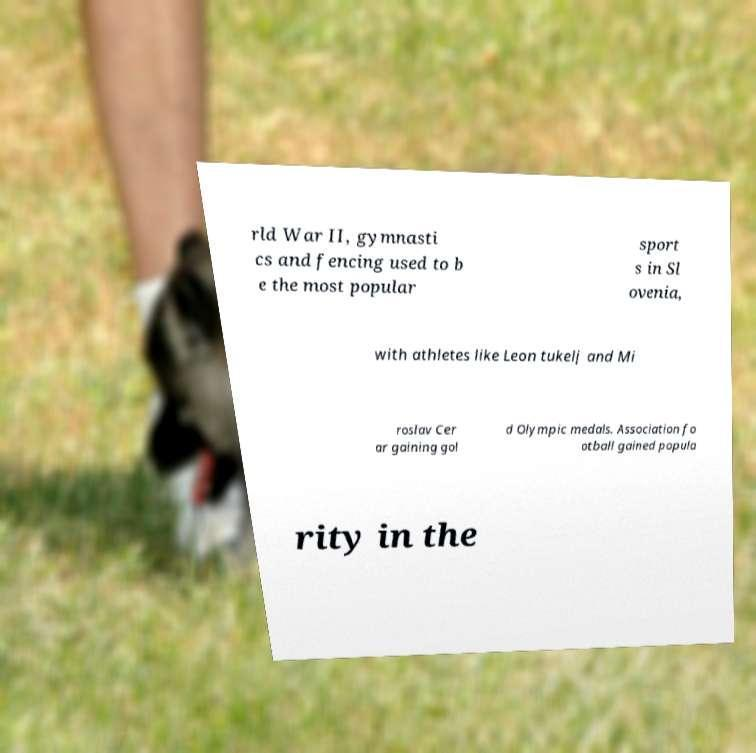Can you read and provide the text displayed in the image?This photo seems to have some interesting text. Can you extract and type it out for me? rld War II, gymnasti cs and fencing used to b e the most popular sport s in Sl ovenia, with athletes like Leon tukelj and Mi roslav Cer ar gaining gol d Olympic medals. Association fo otball gained popula rity in the 